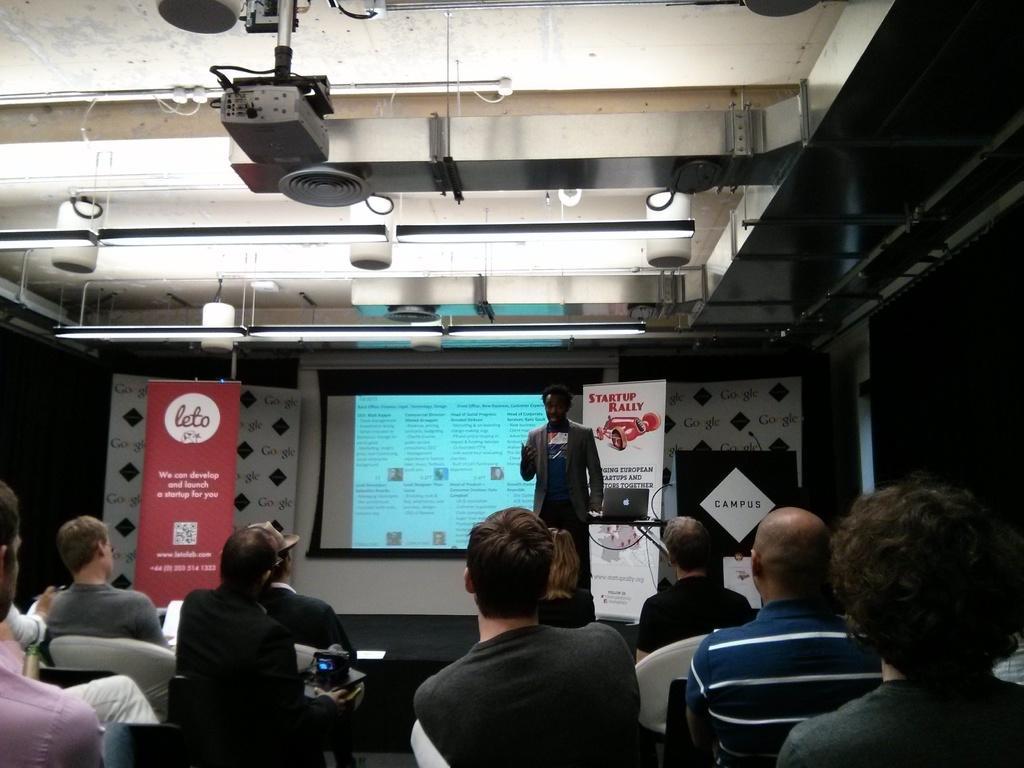How would you summarize this image in a sentence or two? In this image there are some persons sitting on the chairs in the bottom of this image. There is one person standing in middle of this image and there is a screen in the background. There are some advertising boards on the left side of this image and on the right side of this image as well. There are some lights arranged on the top of this image and there is one projector is on the top of this image. 